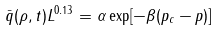Convert formula to latex. <formula><loc_0><loc_0><loc_500><loc_500>\bar { q } ( \rho , t ) L ^ { 0 . 1 3 } = \alpha \exp [ - \beta ( p _ { c } - p ) ]</formula> 